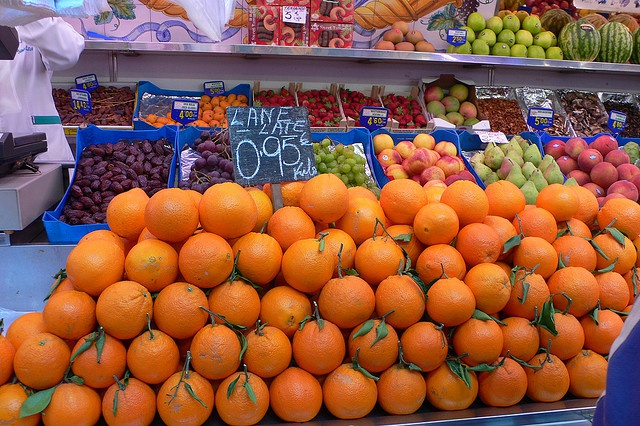Describe the objects in this image and their specific colors. I can see orange in gray, red, brown, maroon, and orange tones, people in gray, violet, lavender, and darkgray tones, apple in gray and olive tones, apple in gray, orange, salmon, brown, and red tones, and people in gray, navy, darkgray, darkblue, and purple tones in this image. 